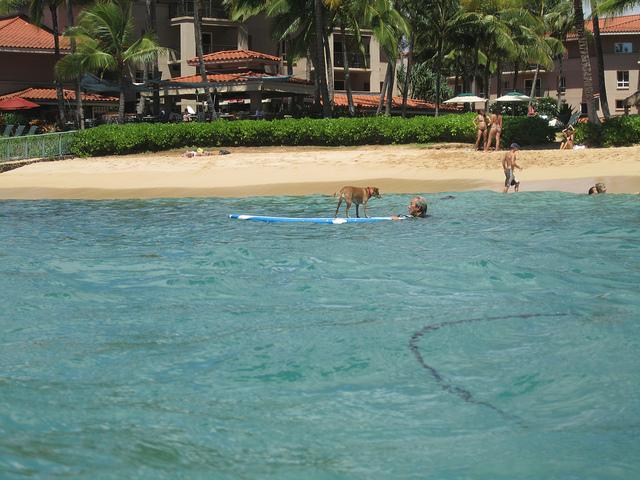What is preventing the dog from being submerged in the water?

Choices:
A) surf board
B) owner
C) leash
D) collar surf board 